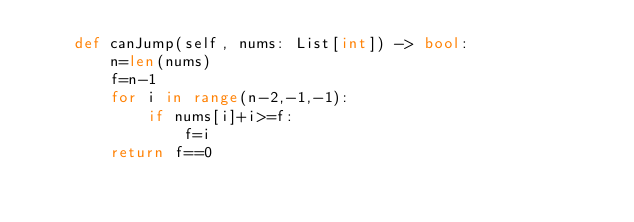Convert code to text. <code><loc_0><loc_0><loc_500><loc_500><_Python_>    def canJump(self, nums: List[int]) -> bool:
        n=len(nums)
        f=n-1
        for i in range(n-2,-1,-1):
            if nums[i]+i>=f:
                f=i
        return f==0
</code> 